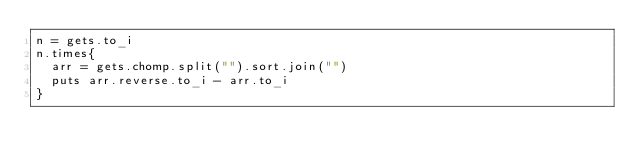Convert code to text. <code><loc_0><loc_0><loc_500><loc_500><_Ruby_>n = gets.to_i
n.times{
  arr = gets.chomp.split("").sort.join("")
  puts arr.reverse.to_i - arr.to_i
}</code> 